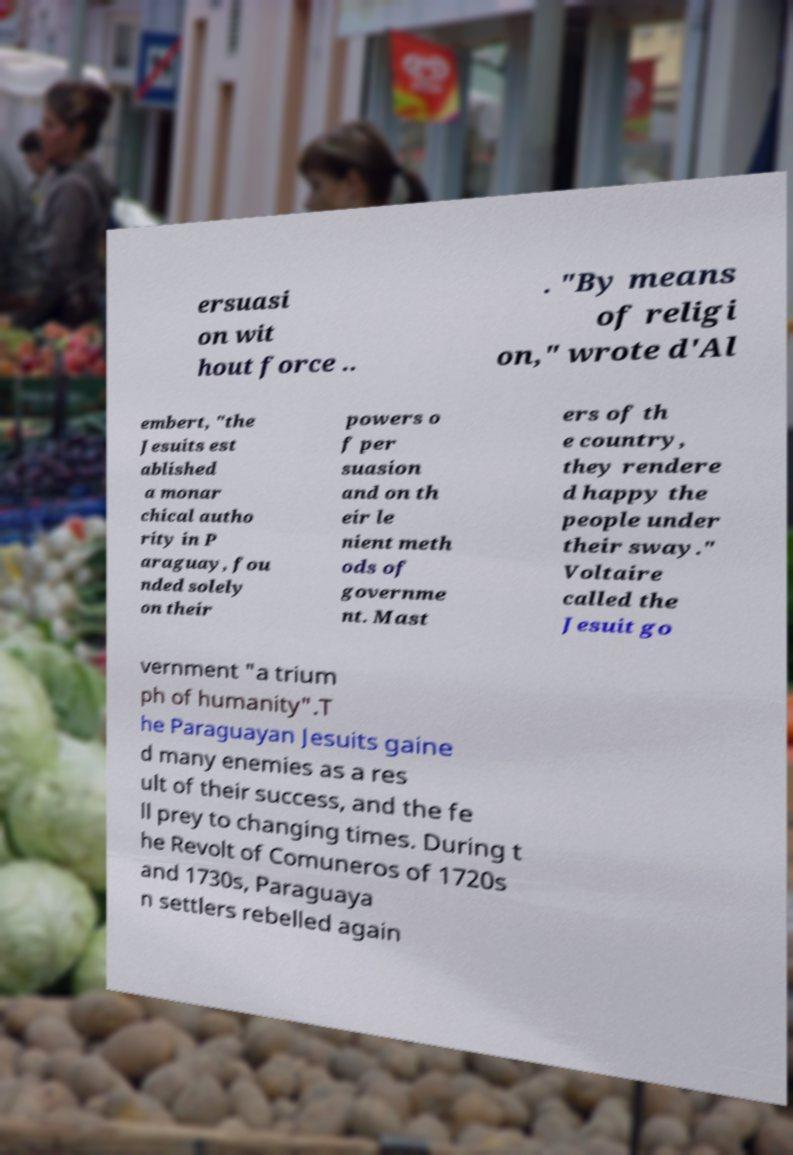For documentation purposes, I need the text within this image transcribed. Could you provide that? ersuasi on wit hout force .. . "By means of religi on," wrote d'Al embert, "the Jesuits est ablished a monar chical autho rity in P araguay, fou nded solely on their powers o f per suasion and on th eir le nient meth ods of governme nt. Mast ers of th e country, they rendere d happy the people under their sway." Voltaire called the Jesuit go vernment "a trium ph of humanity".T he Paraguayan Jesuits gaine d many enemies as a res ult of their success, and the fe ll prey to changing times. During t he Revolt of Comuneros of 1720s and 1730s, Paraguaya n settlers rebelled again 